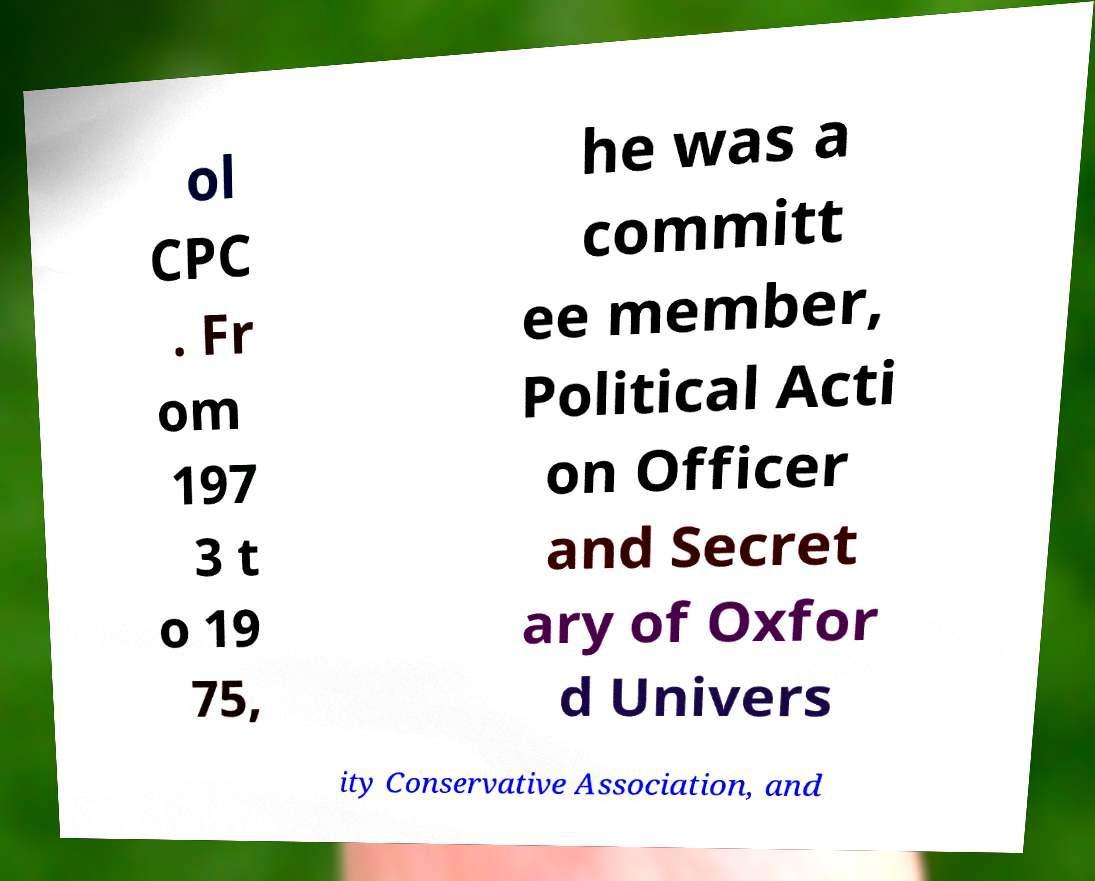For documentation purposes, I need the text within this image transcribed. Could you provide that? ol CPC . Fr om 197 3 t o 19 75, he was a committ ee member, Political Acti on Officer and Secret ary of Oxfor d Univers ity Conservative Association, and 